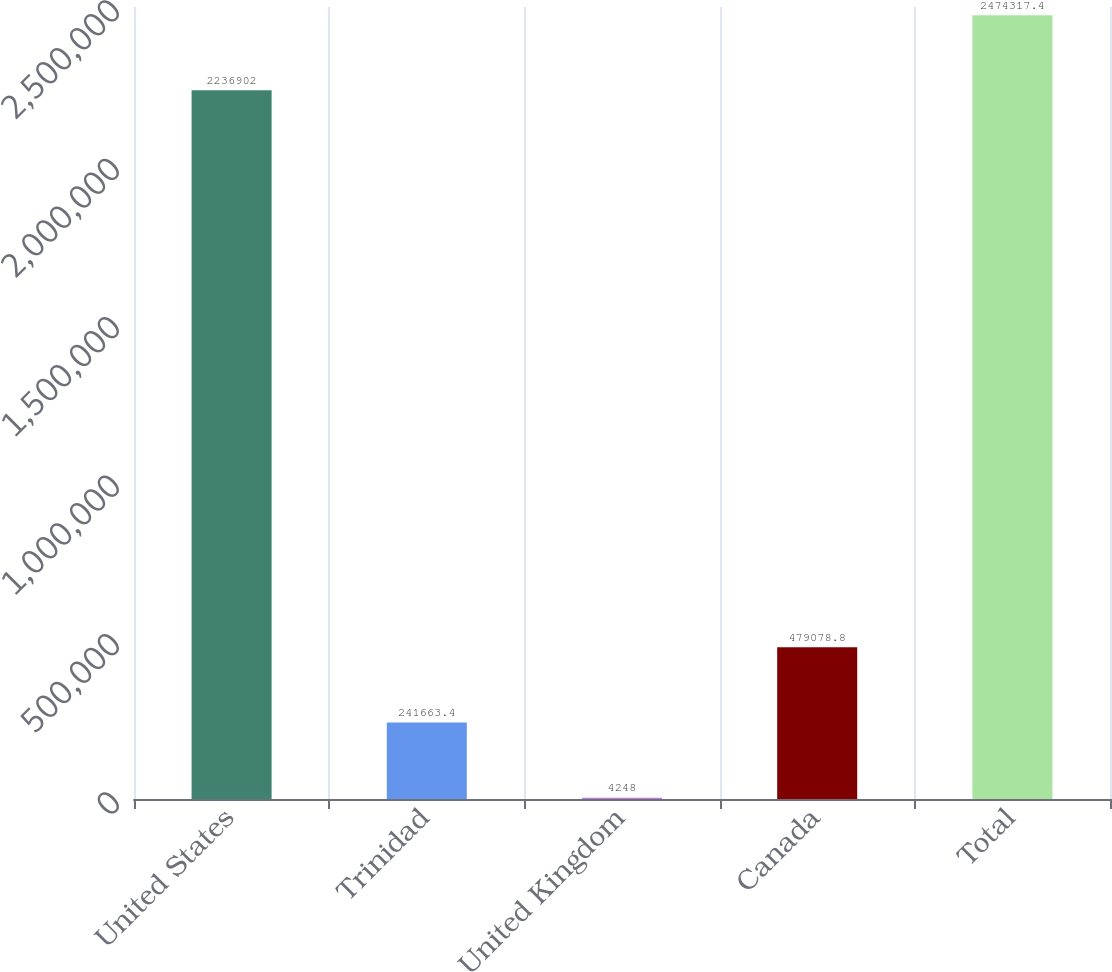Convert chart. <chart><loc_0><loc_0><loc_500><loc_500><bar_chart><fcel>United States<fcel>Trinidad<fcel>United Kingdom<fcel>Canada<fcel>Total<nl><fcel>2.2369e+06<fcel>241663<fcel>4248<fcel>479079<fcel>2.47432e+06<nl></chart> 